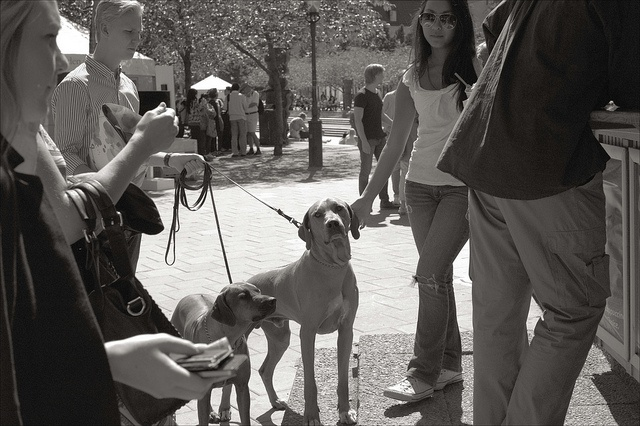Describe the objects in this image and their specific colors. I can see people in black and gray tones, people in black, gray, white, and darkgray tones, people in black and gray tones, dog in black, gray, lightgray, and darkgray tones, and people in black, gray, lightgray, and darkgray tones in this image. 